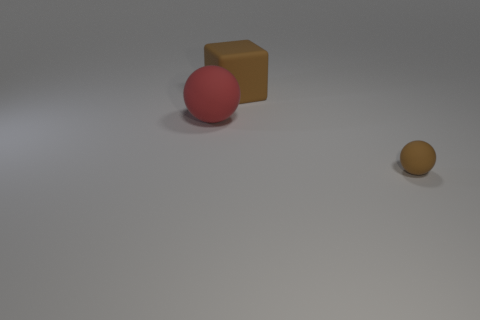Subtract all spheres. How many objects are left? 1 Add 2 brown objects. How many objects exist? 5 Subtract 0 red cylinders. How many objects are left? 3 Subtract all brown spheres. Subtract all green cylinders. How many spheres are left? 1 Subtract all small spheres. Subtract all matte cubes. How many objects are left? 1 Add 1 matte balls. How many matte balls are left? 3 Add 1 rubber spheres. How many rubber spheres exist? 3 